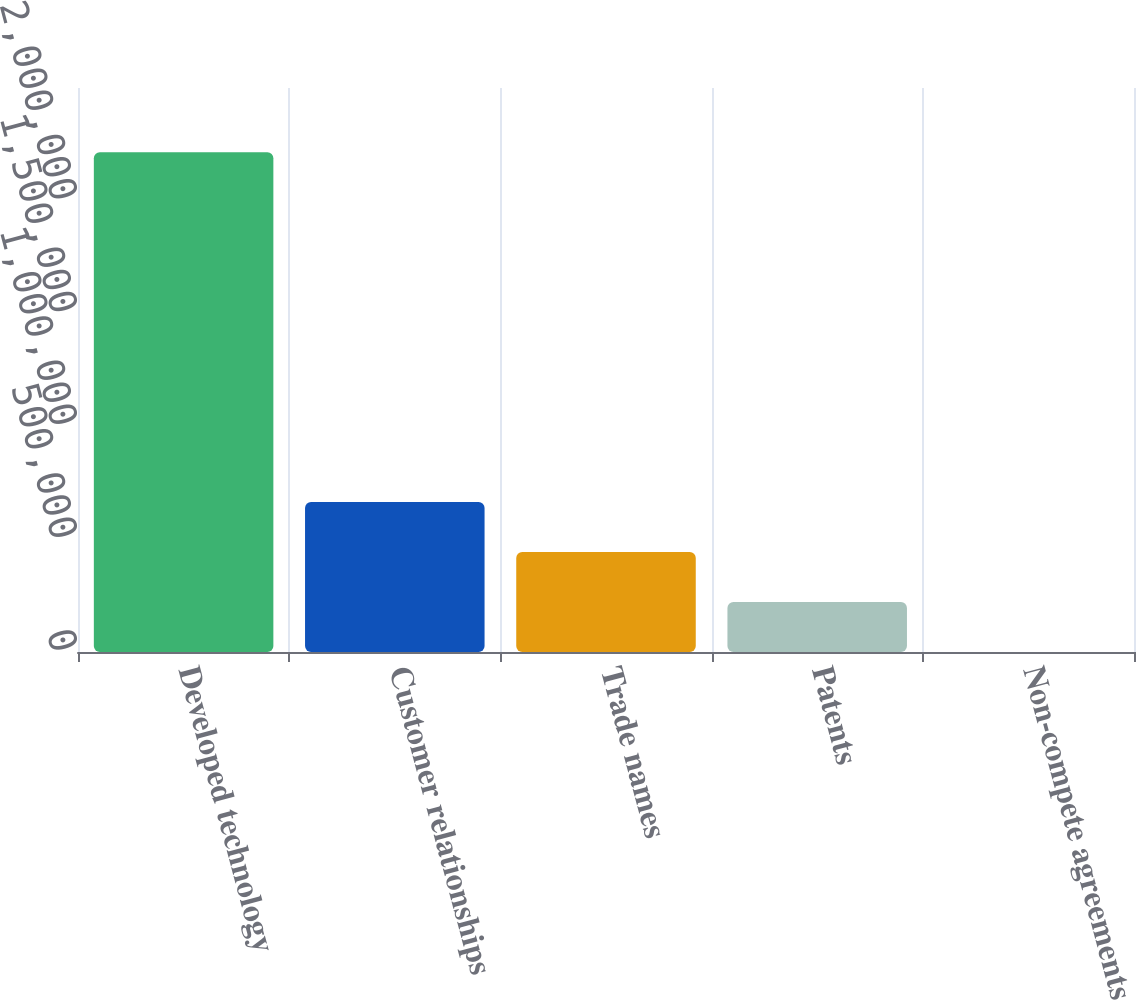Convert chart. <chart><loc_0><loc_0><loc_500><loc_500><bar_chart><fcel>Developed technology<fcel>Customer relationships<fcel>Trade names<fcel>Patents<fcel>Non-compete agreements<nl><fcel>2.21532e+06<fcel>664805<fcel>443302<fcel>221800<fcel>297<nl></chart> 